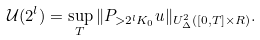<formula> <loc_0><loc_0><loc_500><loc_500>\mathcal { U } ( 2 ^ { l } ) = \sup _ { T } \| P _ { > 2 ^ { l } K _ { 0 } } u \| _ { U _ { \Delta } ^ { 2 } ( [ 0 , T ] \times R ) } .</formula> 